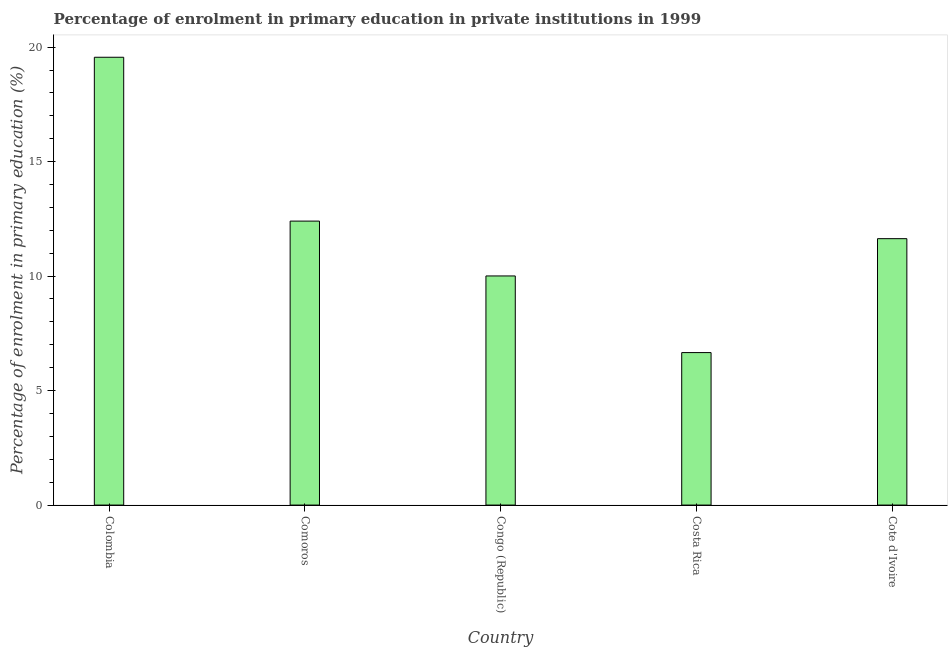What is the title of the graph?
Offer a terse response. Percentage of enrolment in primary education in private institutions in 1999. What is the label or title of the X-axis?
Provide a short and direct response. Country. What is the label or title of the Y-axis?
Provide a succinct answer. Percentage of enrolment in primary education (%). What is the enrolment percentage in primary education in Cote d'Ivoire?
Offer a terse response. 11.63. Across all countries, what is the maximum enrolment percentage in primary education?
Offer a terse response. 19.56. Across all countries, what is the minimum enrolment percentage in primary education?
Make the answer very short. 6.66. What is the sum of the enrolment percentage in primary education?
Keep it short and to the point. 60.26. What is the difference between the enrolment percentage in primary education in Colombia and Cote d'Ivoire?
Give a very brief answer. 7.92. What is the average enrolment percentage in primary education per country?
Your answer should be very brief. 12.05. What is the median enrolment percentage in primary education?
Keep it short and to the point. 11.63. In how many countries, is the enrolment percentage in primary education greater than 8 %?
Your answer should be compact. 4. What is the ratio of the enrolment percentage in primary education in Costa Rica to that in Cote d'Ivoire?
Your answer should be very brief. 0.57. Is the enrolment percentage in primary education in Colombia less than that in Congo (Republic)?
Offer a very short reply. No. Is the difference between the enrolment percentage in primary education in Colombia and Cote d'Ivoire greater than the difference between any two countries?
Offer a terse response. No. What is the difference between the highest and the second highest enrolment percentage in primary education?
Your answer should be compact. 7.16. Is the sum of the enrolment percentage in primary education in Colombia and Comoros greater than the maximum enrolment percentage in primary education across all countries?
Ensure brevity in your answer.  Yes. What is the difference between the highest and the lowest enrolment percentage in primary education?
Ensure brevity in your answer.  12.9. How many bars are there?
Provide a short and direct response. 5. Are the values on the major ticks of Y-axis written in scientific E-notation?
Keep it short and to the point. No. What is the Percentage of enrolment in primary education (%) of Colombia?
Offer a terse response. 19.56. What is the Percentage of enrolment in primary education (%) of Comoros?
Ensure brevity in your answer.  12.4. What is the Percentage of enrolment in primary education (%) in Congo (Republic)?
Provide a short and direct response. 10.01. What is the Percentage of enrolment in primary education (%) in Costa Rica?
Keep it short and to the point. 6.66. What is the Percentage of enrolment in primary education (%) in Cote d'Ivoire?
Offer a very short reply. 11.63. What is the difference between the Percentage of enrolment in primary education (%) in Colombia and Comoros?
Provide a succinct answer. 7.16. What is the difference between the Percentage of enrolment in primary education (%) in Colombia and Congo (Republic)?
Ensure brevity in your answer.  9.55. What is the difference between the Percentage of enrolment in primary education (%) in Colombia and Costa Rica?
Ensure brevity in your answer.  12.9. What is the difference between the Percentage of enrolment in primary education (%) in Colombia and Cote d'Ivoire?
Provide a short and direct response. 7.92. What is the difference between the Percentage of enrolment in primary education (%) in Comoros and Congo (Republic)?
Your answer should be compact. 2.39. What is the difference between the Percentage of enrolment in primary education (%) in Comoros and Costa Rica?
Make the answer very short. 5.74. What is the difference between the Percentage of enrolment in primary education (%) in Comoros and Cote d'Ivoire?
Give a very brief answer. 0.77. What is the difference between the Percentage of enrolment in primary education (%) in Congo (Republic) and Costa Rica?
Ensure brevity in your answer.  3.35. What is the difference between the Percentage of enrolment in primary education (%) in Congo (Republic) and Cote d'Ivoire?
Ensure brevity in your answer.  -1.63. What is the difference between the Percentage of enrolment in primary education (%) in Costa Rica and Cote d'Ivoire?
Ensure brevity in your answer.  -4.98. What is the ratio of the Percentage of enrolment in primary education (%) in Colombia to that in Comoros?
Offer a terse response. 1.58. What is the ratio of the Percentage of enrolment in primary education (%) in Colombia to that in Congo (Republic)?
Keep it short and to the point. 1.95. What is the ratio of the Percentage of enrolment in primary education (%) in Colombia to that in Costa Rica?
Your answer should be very brief. 2.94. What is the ratio of the Percentage of enrolment in primary education (%) in Colombia to that in Cote d'Ivoire?
Keep it short and to the point. 1.68. What is the ratio of the Percentage of enrolment in primary education (%) in Comoros to that in Congo (Republic)?
Offer a terse response. 1.24. What is the ratio of the Percentage of enrolment in primary education (%) in Comoros to that in Costa Rica?
Your response must be concise. 1.86. What is the ratio of the Percentage of enrolment in primary education (%) in Comoros to that in Cote d'Ivoire?
Make the answer very short. 1.07. What is the ratio of the Percentage of enrolment in primary education (%) in Congo (Republic) to that in Costa Rica?
Make the answer very short. 1.5. What is the ratio of the Percentage of enrolment in primary education (%) in Congo (Republic) to that in Cote d'Ivoire?
Offer a very short reply. 0.86. What is the ratio of the Percentage of enrolment in primary education (%) in Costa Rica to that in Cote d'Ivoire?
Your answer should be compact. 0.57. 